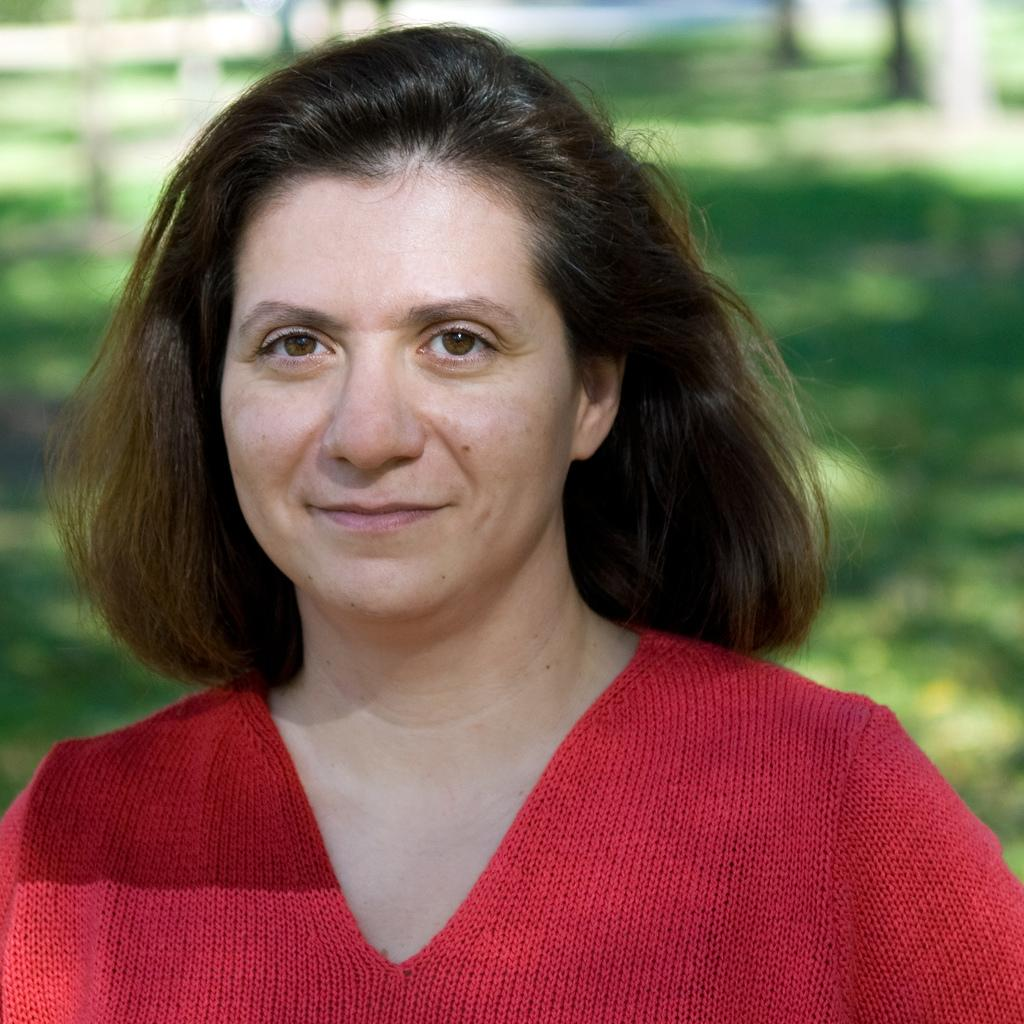Who is the main subject in the image? There is a lady in the center of the image. What can be seen in the background of the image? There is ground and trees visible in the background of the image. What type of gold jewelry is the lady wearing in the image? There is no gold jewelry visible on the lady in the image. What type of beef dish is being prepared in the background of the image? There is no beef dish or any food preparation visible in the image. 